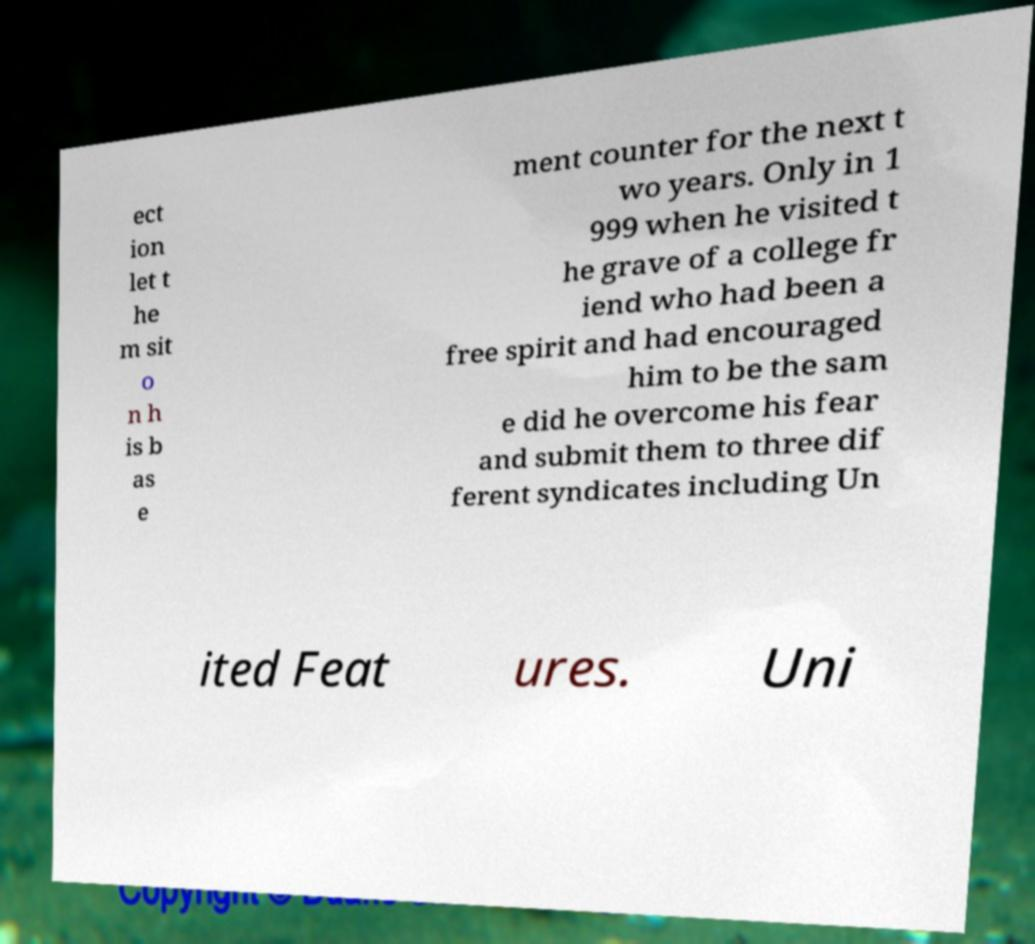Could you extract and type out the text from this image? ect ion let t he m sit o n h is b as e ment counter for the next t wo years. Only in 1 999 when he visited t he grave of a college fr iend who had been a free spirit and had encouraged him to be the sam e did he overcome his fear and submit them to three dif ferent syndicates including Un ited Feat ures. Uni 